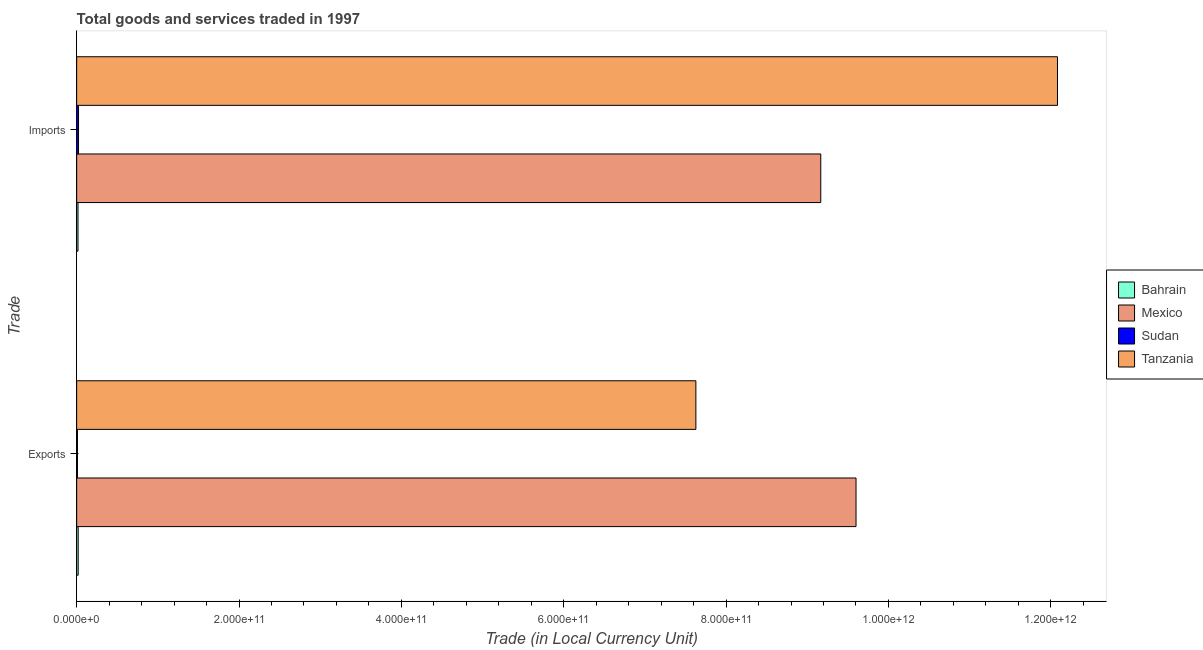How many different coloured bars are there?
Your response must be concise. 4. Are the number of bars per tick equal to the number of legend labels?
Offer a terse response. Yes. Are the number of bars on each tick of the Y-axis equal?
Make the answer very short. Yes. How many bars are there on the 1st tick from the bottom?
Your answer should be compact. 4. What is the label of the 1st group of bars from the top?
Your answer should be compact. Imports. What is the imports of goods and services in Mexico?
Offer a terse response. 9.17e+11. Across all countries, what is the maximum export of goods and services?
Provide a succinct answer. 9.60e+11. Across all countries, what is the minimum export of goods and services?
Your answer should be compact. 9.84e+08. In which country was the imports of goods and services maximum?
Ensure brevity in your answer.  Tanzania. In which country was the export of goods and services minimum?
Your answer should be very brief. Sudan. What is the total imports of goods and services in the graph?
Make the answer very short. 2.13e+12. What is the difference between the imports of goods and services in Mexico and that in Bahrain?
Provide a succinct answer. 9.15e+11. What is the difference between the export of goods and services in Mexico and the imports of goods and services in Tanzania?
Your answer should be very brief. -2.48e+11. What is the average export of goods and services per country?
Make the answer very short. 4.31e+11. What is the difference between the export of goods and services and imports of goods and services in Sudan?
Provide a succinct answer. -1.32e+09. In how many countries, is the imports of goods and services greater than 360000000000 LCU?
Provide a short and direct response. 2. What is the ratio of the export of goods and services in Tanzania to that in Sudan?
Your answer should be very brief. 775.55. Is the export of goods and services in Bahrain less than that in Tanzania?
Keep it short and to the point. Yes. What does the 2nd bar from the bottom in Imports represents?
Offer a very short reply. Mexico. How many bars are there?
Provide a short and direct response. 8. Are all the bars in the graph horizontal?
Make the answer very short. Yes. What is the difference between two consecutive major ticks on the X-axis?
Your answer should be very brief. 2.00e+11. Does the graph contain any zero values?
Your answer should be very brief. No. Does the graph contain grids?
Give a very brief answer. No. Where does the legend appear in the graph?
Make the answer very short. Center right. What is the title of the graph?
Your response must be concise. Total goods and services traded in 1997. Does "Central Europe" appear as one of the legend labels in the graph?
Provide a succinct answer. No. What is the label or title of the X-axis?
Ensure brevity in your answer.  Trade (in Local Currency Unit). What is the label or title of the Y-axis?
Give a very brief answer. Trade. What is the Trade (in Local Currency Unit) of Bahrain in Exports?
Keep it short and to the point. 1.89e+09. What is the Trade (in Local Currency Unit) of Mexico in Exports?
Ensure brevity in your answer.  9.60e+11. What is the Trade (in Local Currency Unit) of Sudan in Exports?
Your answer should be very brief. 9.84e+08. What is the Trade (in Local Currency Unit) of Tanzania in Exports?
Your answer should be compact. 7.63e+11. What is the Trade (in Local Currency Unit) in Bahrain in Imports?
Provide a short and direct response. 1.66e+09. What is the Trade (in Local Currency Unit) of Mexico in Imports?
Keep it short and to the point. 9.17e+11. What is the Trade (in Local Currency Unit) of Sudan in Imports?
Offer a very short reply. 2.30e+09. What is the Trade (in Local Currency Unit) of Tanzania in Imports?
Give a very brief answer. 1.21e+12. Across all Trade, what is the maximum Trade (in Local Currency Unit) of Bahrain?
Keep it short and to the point. 1.89e+09. Across all Trade, what is the maximum Trade (in Local Currency Unit) in Mexico?
Provide a succinct answer. 9.60e+11. Across all Trade, what is the maximum Trade (in Local Currency Unit) in Sudan?
Ensure brevity in your answer.  2.30e+09. Across all Trade, what is the maximum Trade (in Local Currency Unit) of Tanzania?
Offer a very short reply. 1.21e+12. Across all Trade, what is the minimum Trade (in Local Currency Unit) of Bahrain?
Ensure brevity in your answer.  1.66e+09. Across all Trade, what is the minimum Trade (in Local Currency Unit) in Mexico?
Provide a short and direct response. 9.17e+11. Across all Trade, what is the minimum Trade (in Local Currency Unit) in Sudan?
Give a very brief answer. 9.84e+08. Across all Trade, what is the minimum Trade (in Local Currency Unit) in Tanzania?
Offer a very short reply. 7.63e+11. What is the total Trade (in Local Currency Unit) of Bahrain in the graph?
Give a very brief answer. 3.55e+09. What is the total Trade (in Local Currency Unit) of Mexico in the graph?
Provide a short and direct response. 1.88e+12. What is the total Trade (in Local Currency Unit) of Sudan in the graph?
Provide a short and direct response. 3.29e+09. What is the total Trade (in Local Currency Unit) in Tanzania in the graph?
Keep it short and to the point. 1.97e+12. What is the difference between the Trade (in Local Currency Unit) of Bahrain in Exports and that in Imports?
Offer a terse response. 2.29e+08. What is the difference between the Trade (in Local Currency Unit) in Mexico in Exports and that in Imports?
Provide a short and direct response. 4.34e+1. What is the difference between the Trade (in Local Currency Unit) of Sudan in Exports and that in Imports?
Keep it short and to the point. -1.32e+09. What is the difference between the Trade (in Local Currency Unit) of Tanzania in Exports and that in Imports?
Your answer should be very brief. -4.45e+11. What is the difference between the Trade (in Local Currency Unit) in Bahrain in Exports and the Trade (in Local Currency Unit) in Mexico in Imports?
Ensure brevity in your answer.  -9.15e+11. What is the difference between the Trade (in Local Currency Unit) in Bahrain in Exports and the Trade (in Local Currency Unit) in Sudan in Imports?
Give a very brief answer. -4.16e+08. What is the difference between the Trade (in Local Currency Unit) of Bahrain in Exports and the Trade (in Local Currency Unit) of Tanzania in Imports?
Offer a terse response. -1.21e+12. What is the difference between the Trade (in Local Currency Unit) in Mexico in Exports and the Trade (in Local Currency Unit) in Sudan in Imports?
Offer a terse response. 9.58e+11. What is the difference between the Trade (in Local Currency Unit) of Mexico in Exports and the Trade (in Local Currency Unit) of Tanzania in Imports?
Keep it short and to the point. -2.48e+11. What is the difference between the Trade (in Local Currency Unit) of Sudan in Exports and the Trade (in Local Currency Unit) of Tanzania in Imports?
Your answer should be very brief. -1.21e+12. What is the average Trade (in Local Currency Unit) in Bahrain per Trade?
Your answer should be compact. 1.77e+09. What is the average Trade (in Local Currency Unit) of Mexico per Trade?
Make the answer very short. 9.38e+11. What is the average Trade (in Local Currency Unit) of Sudan per Trade?
Keep it short and to the point. 1.64e+09. What is the average Trade (in Local Currency Unit) of Tanzania per Trade?
Make the answer very short. 9.86e+11. What is the difference between the Trade (in Local Currency Unit) in Bahrain and Trade (in Local Currency Unit) in Mexico in Exports?
Provide a short and direct response. -9.58e+11. What is the difference between the Trade (in Local Currency Unit) of Bahrain and Trade (in Local Currency Unit) of Sudan in Exports?
Provide a succinct answer. 9.04e+08. What is the difference between the Trade (in Local Currency Unit) of Bahrain and Trade (in Local Currency Unit) of Tanzania in Exports?
Offer a very short reply. -7.61e+11. What is the difference between the Trade (in Local Currency Unit) in Mexico and Trade (in Local Currency Unit) in Sudan in Exports?
Offer a very short reply. 9.59e+11. What is the difference between the Trade (in Local Currency Unit) of Mexico and Trade (in Local Currency Unit) of Tanzania in Exports?
Keep it short and to the point. 1.97e+11. What is the difference between the Trade (in Local Currency Unit) in Sudan and Trade (in Local Currency Unit) in Tanzania in Exports?
Make the answer very short. -7.62e+11. What is the difference between the Trade (in Local Currency Unit) in Bahrain and Trade (in Local Currency Unit) in Mexico in Imports?
Give a very brief answer. -9.15e+11. What is the difference between the Trade (in Local Currency Unit) of Bahrain and Trade (in Local Currency Unit) of Sudan in Imports?
Your response must be concise. -6.44e+08. What is the difference between the Trade (in Local Currency Unit) in Bahrain and Trade (in Local Currency Unit) in Tanzania in Imports?
Provide a short and direct response. -1.21e+12. What is the difference between the Trade (in Local Currency Unit) in Mexico and Trade (in Local Currency Unit) in Sudan in Imports?
Offer a terse response. 9.14e+11. What is the difference between the Trade (in Local Currency Unit) of Mexico and Trade (in Local Currency Unit) of Tanzania in Imports?
Your answer should be compact. -2.92e+11. What is the difference between the Trade (in Local Currency Unit) in Sudan and Trade (in Local Currency Unit) in Tanzania in Imports?
Offer a terse response. -1.21e+12. What is the ratio of the Trade (in Local Currency Unit) of Bahrain in Exports to that in Imports?
Offer a terse response. 1.14. What is the ratio of the Trade (in Local Currency Unit) of Mexico in Exports to that in Imports?
Provide a short and direct response. 1.05. What is the ratio of the Trade (in Local Currency Unit) in Sudan in Exports to that in Imports?
Your answer should be compact. 0.43. What is the ratio of the Trade (in Local Currency Unit) in Tanzania in Exports to that in Imports?
Your response must be concise. 0.63. What is the difference between the highest and the second highest Trade (in Local Currency Unit) in Bahrain?
Make the answer very short. 2.29e+08. What is the difference between the highest and the second highest Trade (in Local Currency Unit) of Mexico?
Provide a short and direct response. 4.34e+1. What is the difference between the highest and the second highest Trade (in Local Currency Unit) in Sudan?
Your answer should be very brief. 1.32e+09. What is the difference between the highest and the second highest Trade (in Local Currency Unit) in Tanzania?
Provide a short and direct response. 4.45e+11. What is the difference between the highest and the lowest Trade (in Local Currency Unit) of Bahrain?
Ensure brevity in your answer.  2.29e+08. What is the difference between the highest and the lowest Trade (in Local Currency Unit) of Mexico?
Provide a succinct answer. 4.34e+1. What is the difference between the highest and the lowest Trade (in Local Currency Unit) of Sudan?
Your response must be concise. 1.32e+09. What is the difference between the highest and the lowest Trade (in Local Currency Unit) of Tanzania?
Your answer should be very brief. 4.45e+11. 